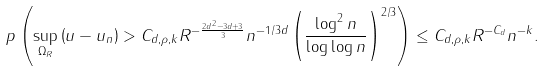<formula> <loc_0><loc_0><loc_500><loc_500>\ p \left ( \sup _ { \Omega _ { R } } \left ( u - u _ { n } \right ) > C _ { d , \rho , k } R ^ { - \frac { 2 d ^ { 2 } - 3 d + 3 } { 3 } } n ^ { - 1 / 3 d } \left ( \frac { \log ^ { 2 } n } { \log \log n } \right ) ^ { 2 / 3 } \right ) \leq C _ { d , \rho , k } R ^ { - C _ { d } } n ^ { - k } .</formula> 